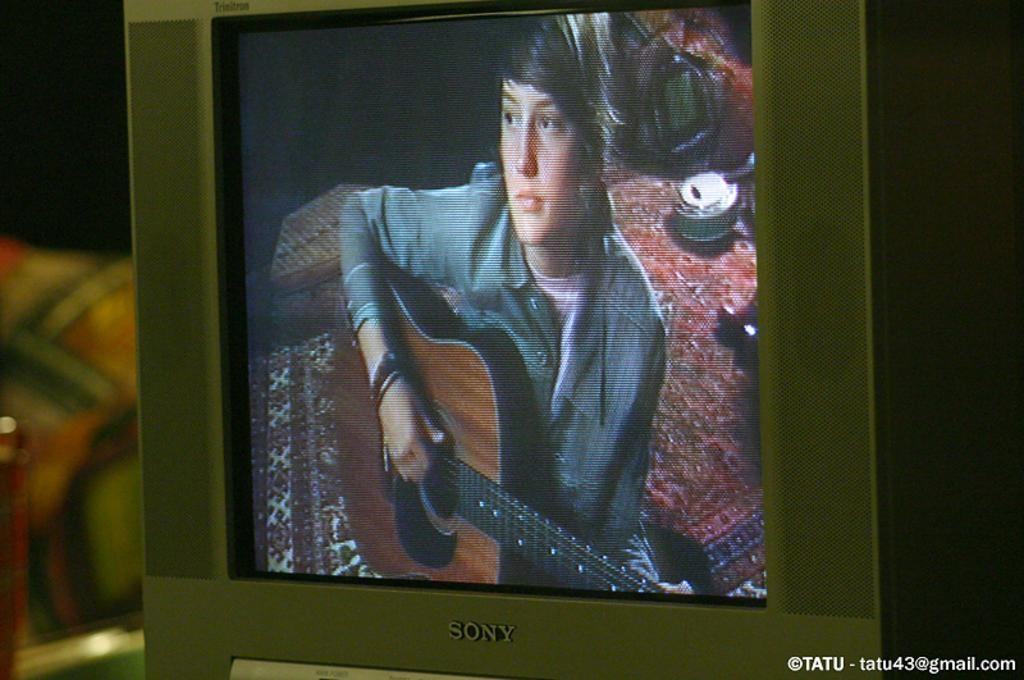<image>
Write a terse but informative summary of the picture. A television with built in speakers was made by sony. 